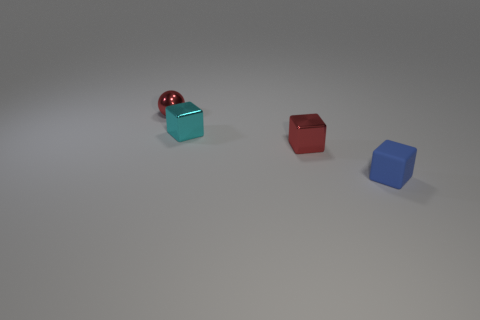Add 3 red cubes. How many objects exist? 7 Subtract all cubes. How many objects are left? 1 Add 2 big metallic objects. How many big metallic objects exist? 2 Subtract 0 gray balls. How many objects are left? 4 Subtract all cyan blocks. Subtract all big matte cubes. How many objects are left? 3 Add 2 tiny blue rubber cubes. How many tiny blue rubber cubes are left? 3 